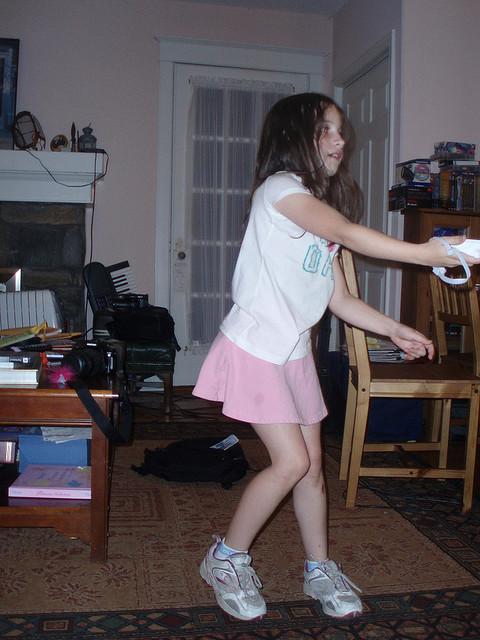What color is the girl's skirt?
Keep it brief. Pink. Is this a boy or a girl?
Write a very short answer. Girl. How many glass panes on door?
Quick response, please. 15. What brand are the girl's shoes?
Give a very brief answer. Nike. What is this person doing?
Quick response, please. Playing wii. How old is the girl?
Keep it brief. 8. What activity are the people in the picture practicing?
Answer briefly. Wii. 